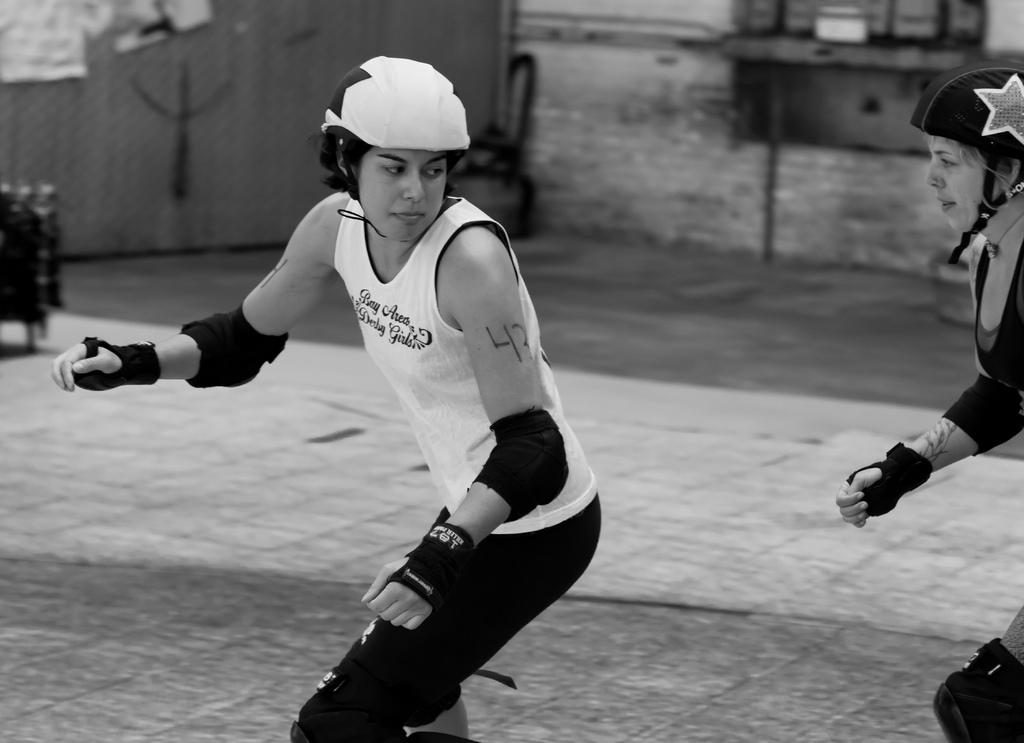How many people are in the image? There are two people in the image. What can be seen in the background of the image? There is ground and a wall visible in the background of the image. Are there any objects present in the background of the image? Yes, there are objects present in the background of the image. What type of net is being used by the people in the image? There is no net present in the image; it only features two people and a background with a wall and objects. 